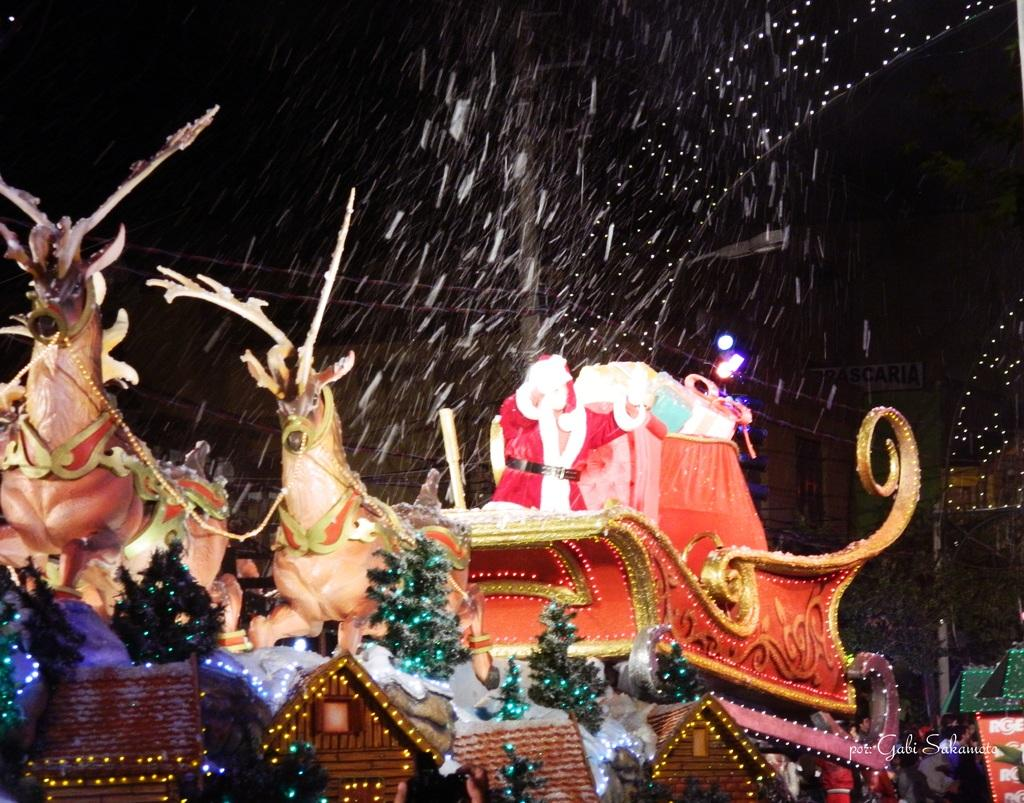What type of objects can be seen in the image? There are toys, a Christmas tree, a sculpture of animals, and a Santa Claus in the image. What else is present in the image? There are houses and lights in the image. Can you describe the watermark on the image? There is a watermark on the image, but its details cannot be discerned from the provided facts. Is there a glove involved in a fight in the image? There is no glove or fight present in the image. Can you tell me what type of pencil is being used to draw the Santa Claus in the image? There is no pencil or drawing activity present in the image; it is a photograph or digital representation of the scene. 